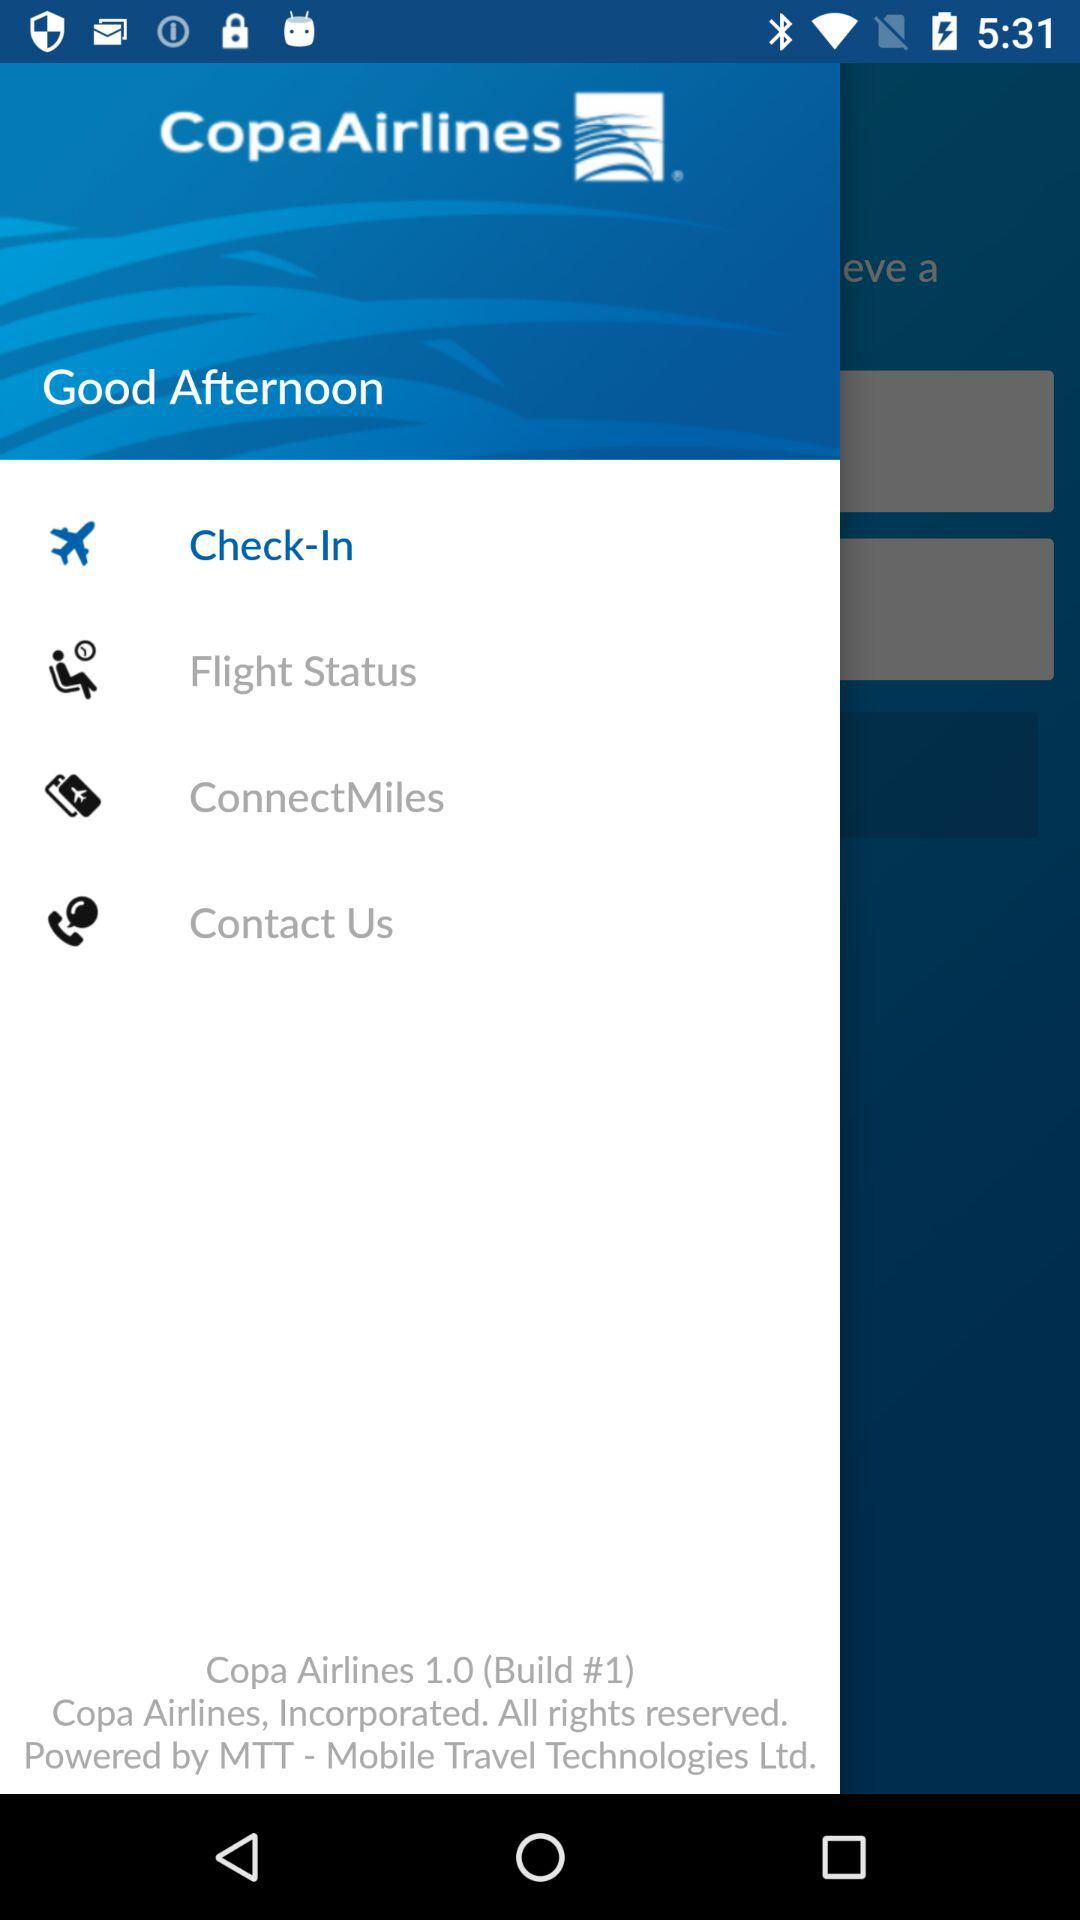Which item has been selected? The selected item is "Check-In". 